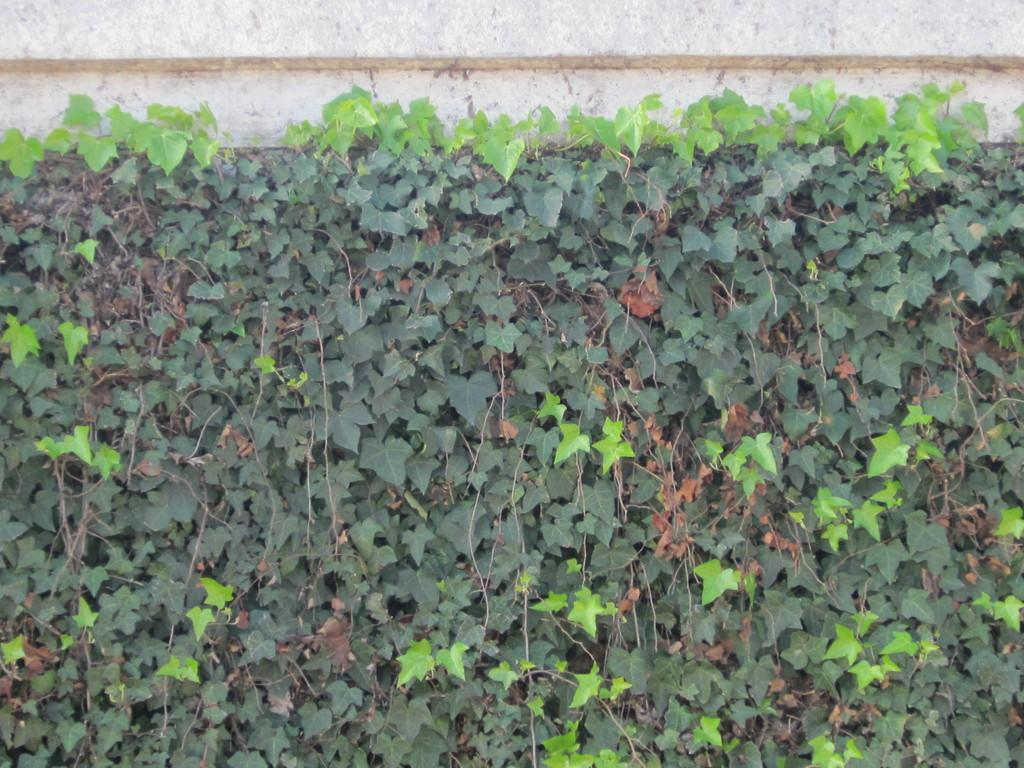What type of living organisms can be seen in the image? Plants can be seen in the image. What is the primary feature visible in the background of the image? There is a wall in the image. What type of legal advice is the plant seeking in the image? There is no indication in the image that the plant is seeking legal advice or interacting with a lawyer. 